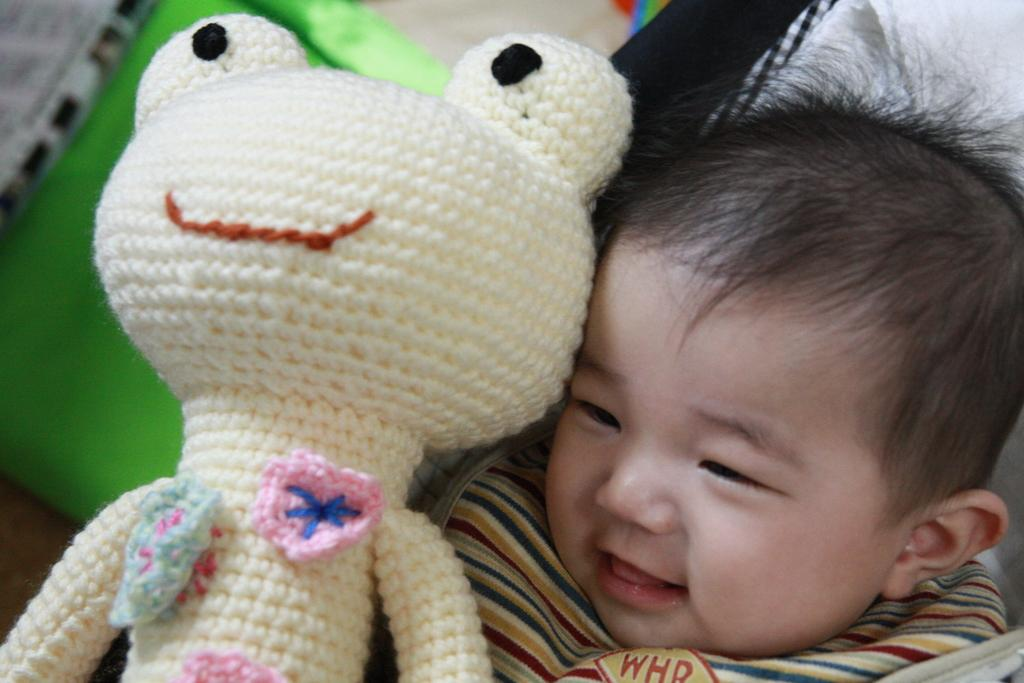What is the main subject of the image? There is a baby in the image. What can be seen with the baby in the image? There is a toy in the image. Are there any other objects present in the image? Yes, there are some other objects in the image. What type of band is performing at the event in the image? There is no band or event present in the image; it features a baby and a toy. Can you tell me where the store is located in the image? There is no store present in the image. 